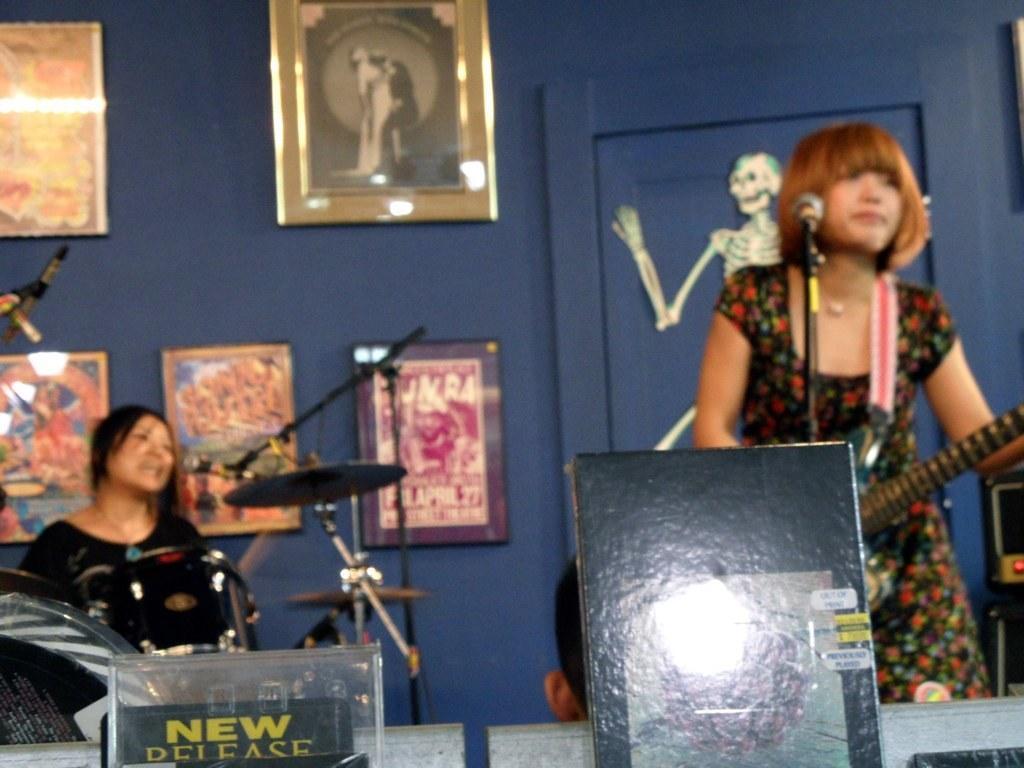Please provide a concise description of this image. Bottom of the image there is a banner. Behind the banner a woman is standing and holding a guitar and there is a microphone. Behind her there is a wall, on the wall there are some frames. Bottom left side of the image there are some drums and there is a microphone. Behind the drums a woman is sitting and smiling. 